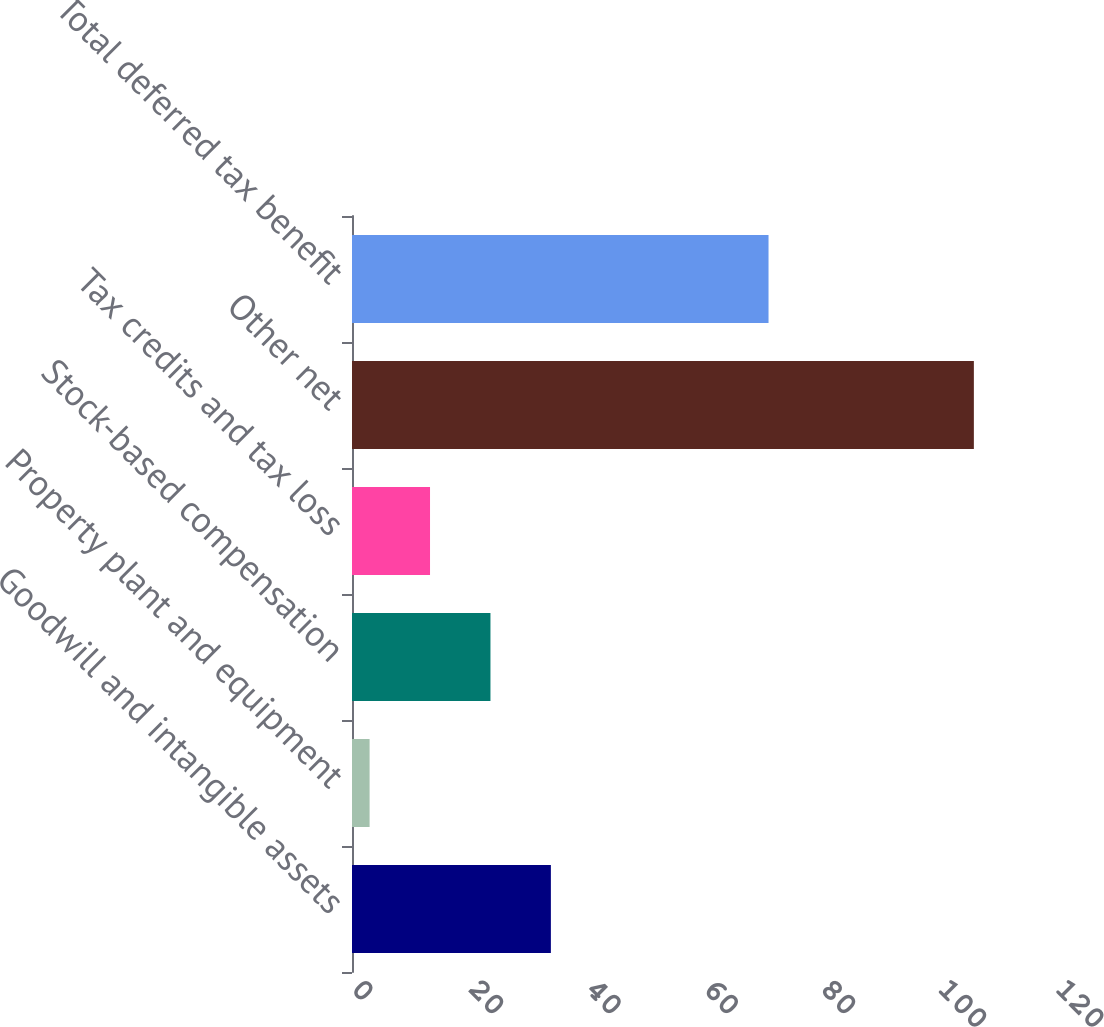Convert chart to OTSL. <chart><loc_0><loc_0><loc_500><loc_500><bar_chart><fcel>Goodwill and intangible assets<fcel>Property plant and equipment<fcel>Stock-based compensation<fcel>Tax credits and tax loss<fcel>Other net<fcel>Total deferred tax benefit<nl><fcel>33.9<fcel>3<fcel>23.6<fcel>13.3<fcel>106<fcel>71<nl></chart> 